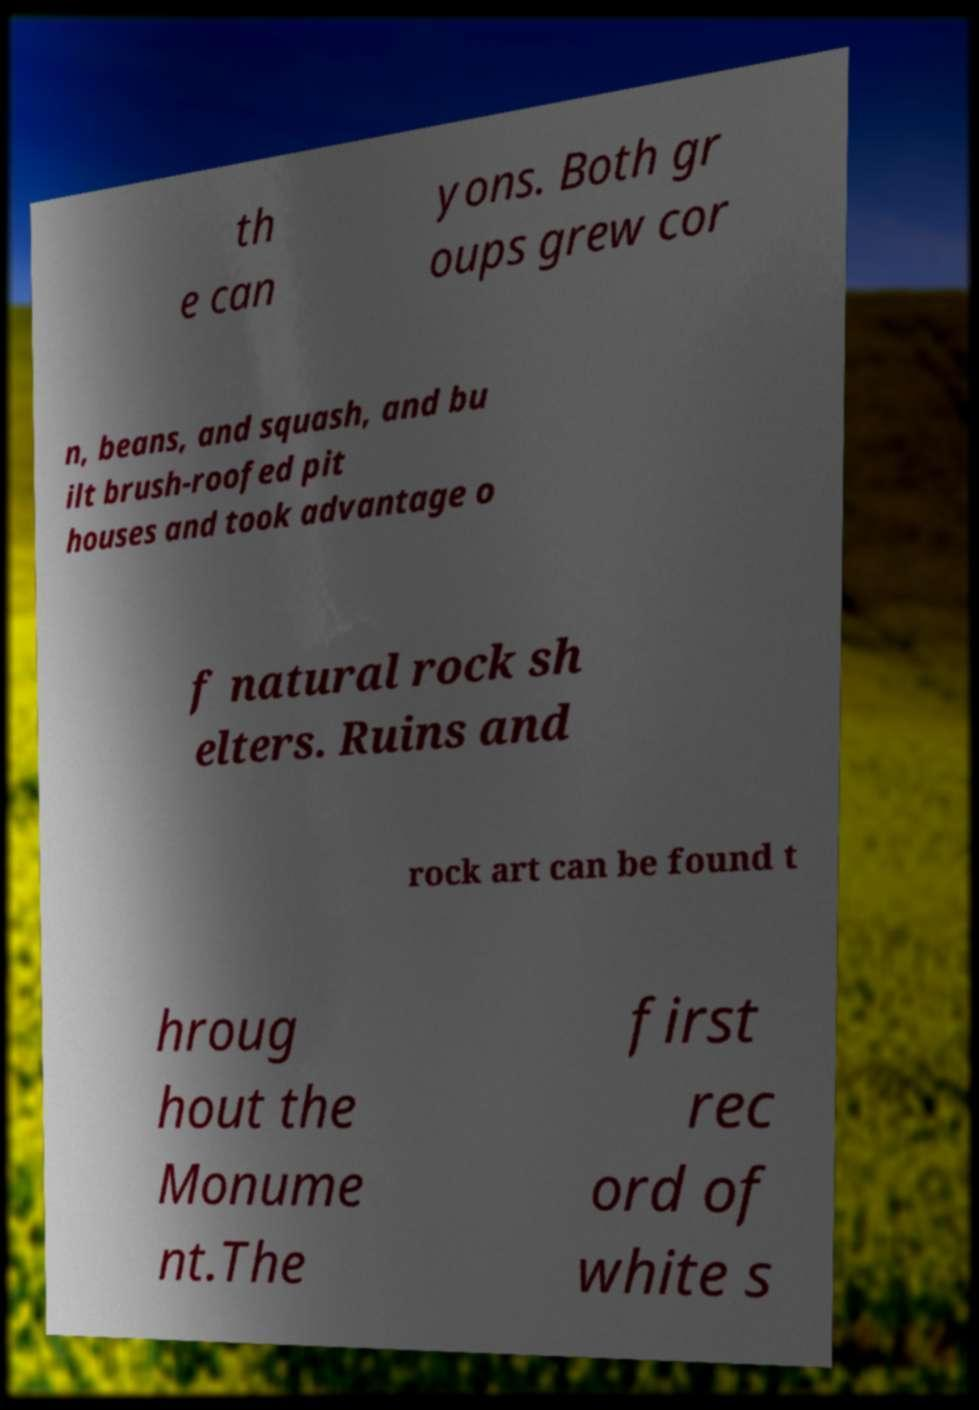Could you assist in decoding the text presented in this image and type it out clearly? th e can yons. Both gr oups grew cor n, beans, and squash, and bu ilt brush-roofed pit houses and took advantage o f natural rock sh elters. Ruins and rock art can be found t hroug hout the Monume nt.The first rec ord of white s 